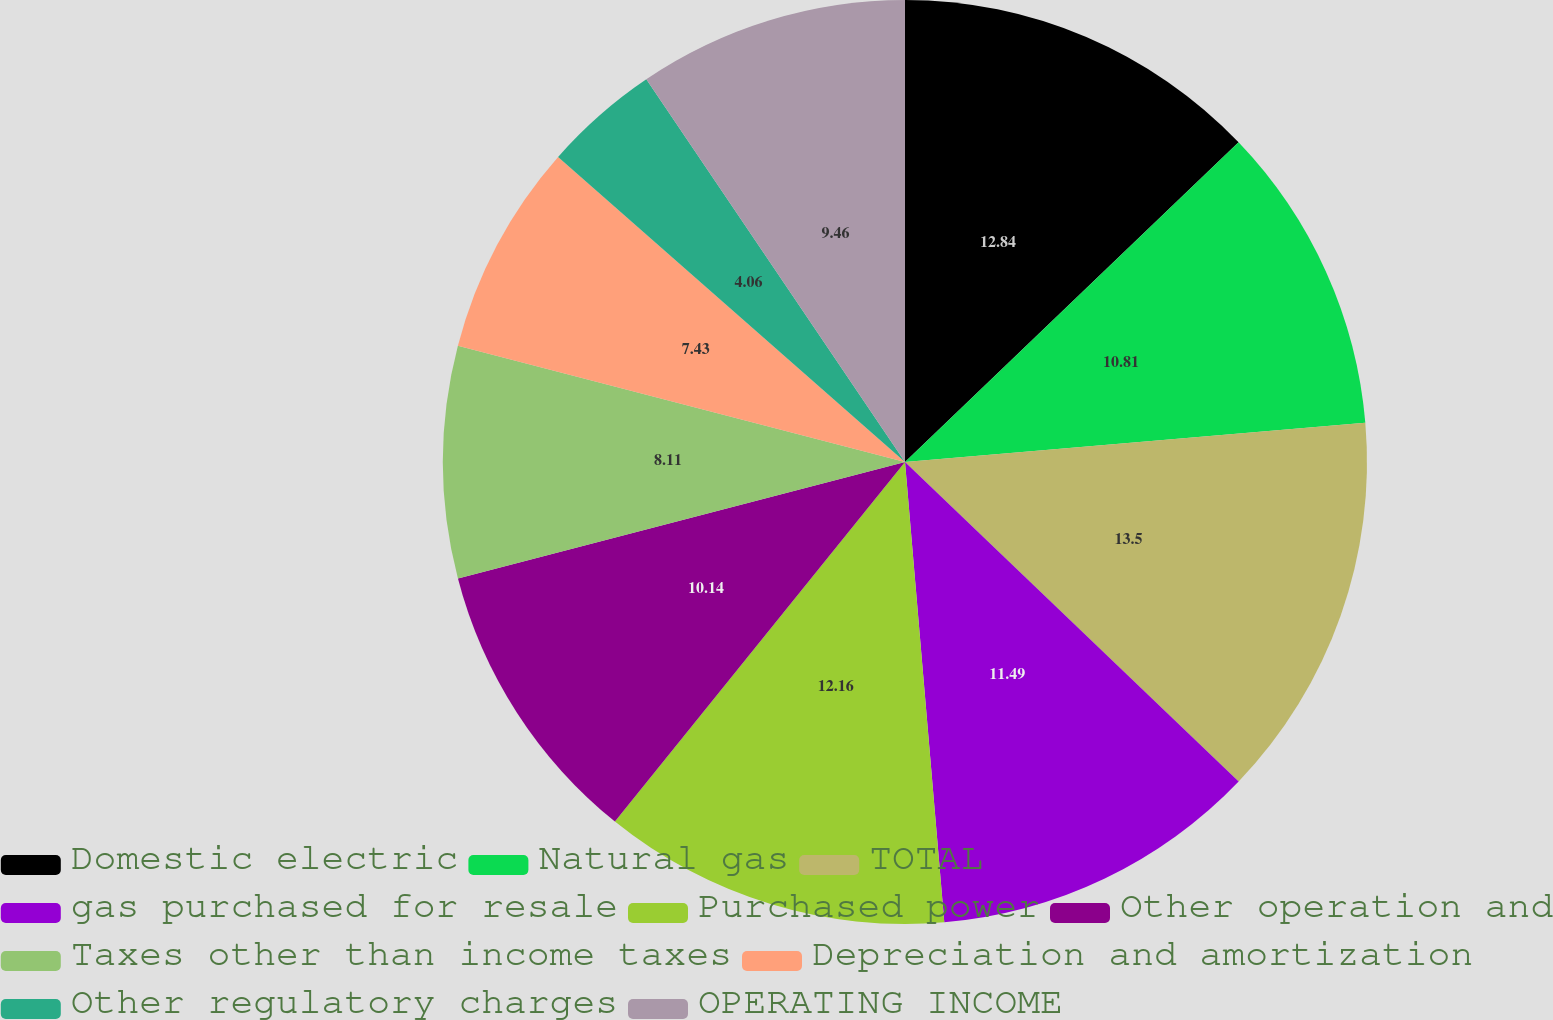<chart> <loc_0><loc_0><loc_500><loc_500><pie_chart><fcel>Domestic electric<fcel>Natural gas<fcel>TOTAL<fcel>gas purchased for resale<fcel>Purchased power<fcel>Other operation and<fcel>Taxes other than income taxes<fcel>Depreciation and amortization<fcel>Other regulatory charges<fcel>OPERATING INCOME<nl><fcel>12.84%<fcel>10.81%<fcel>13.51%<fcel>11.49%<fcel>12.16%<fcel>10.14%<fcel>8.11%<fcel>7.43%<fcel>4.06%<fcel>9.46%<nl></chart> 